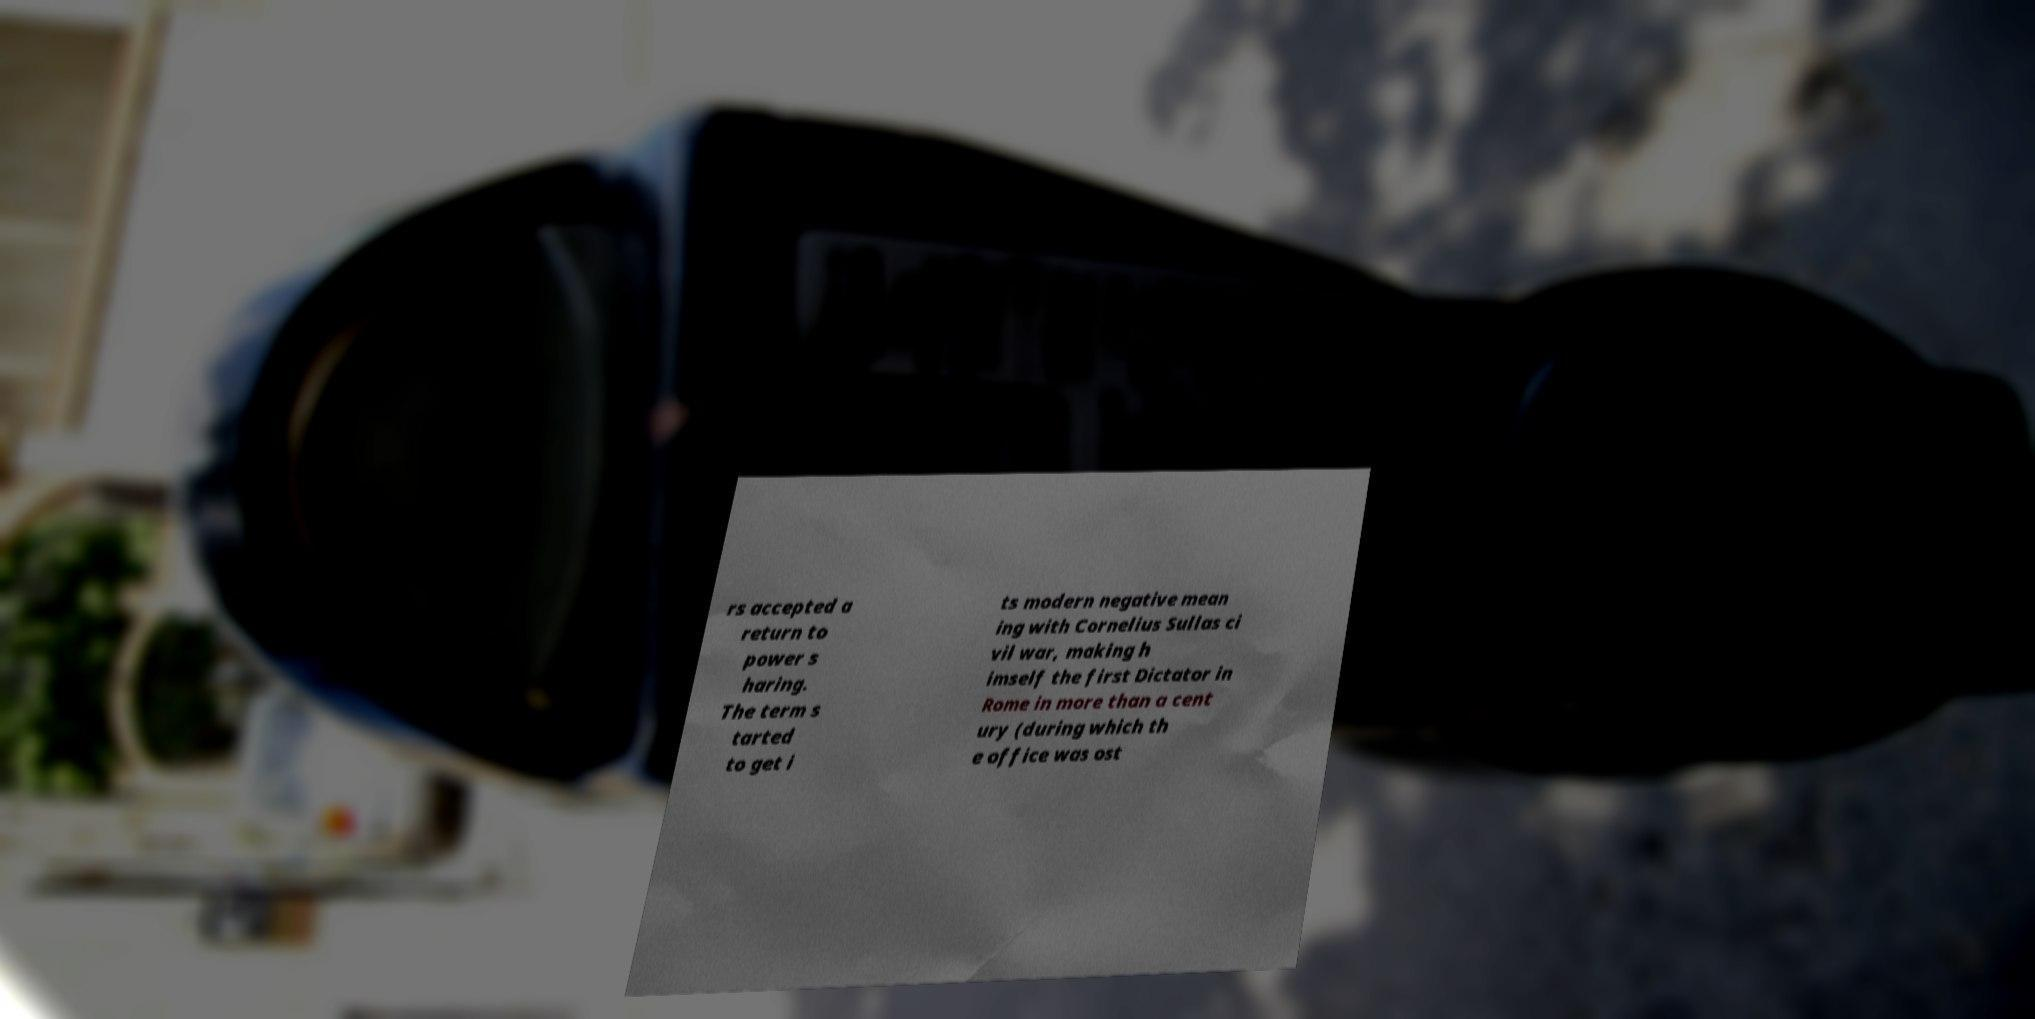Please read and relay the text visible in this image. What does it say? rs accepted a return to power s haring. The term s tarted to get i ts modern negative mean ing with Cornelius Sullas ci vil war, making h imself the first Dictator in Rome in more than a cent ury (during which th e office was ost 